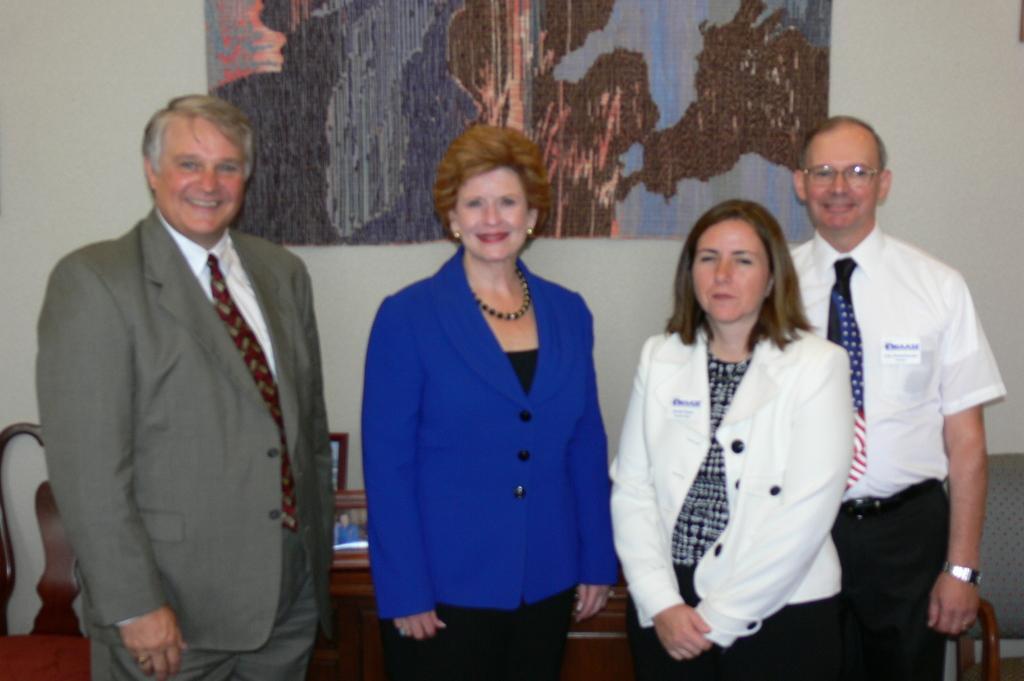In one or two sentences, can you explain what this image depicts? 4 people are standing. 2 people at the left are wearing suit. 2 people at the right are wearing white dress. Behind them there is a table and chair. 